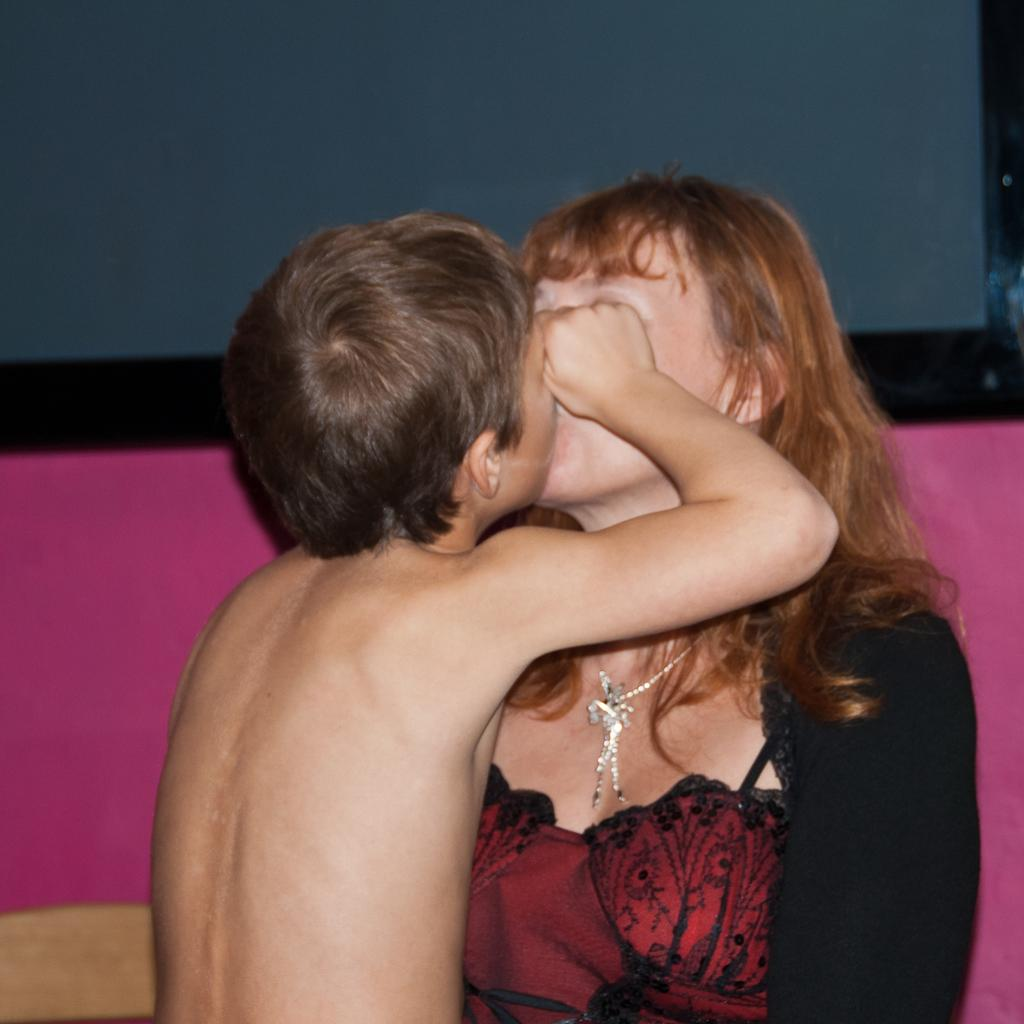Who is in the image with the boy? The boy is kissing a woman in the image. What colors are present in the background of the image? There is a pink color object and a blue color object in the background. What trail can be seen in the image? There is no trail present in the image. What idea does the boy have while kissing the woman? The image does not provide any information about the boy's thoughts or ideas during the kiss. 